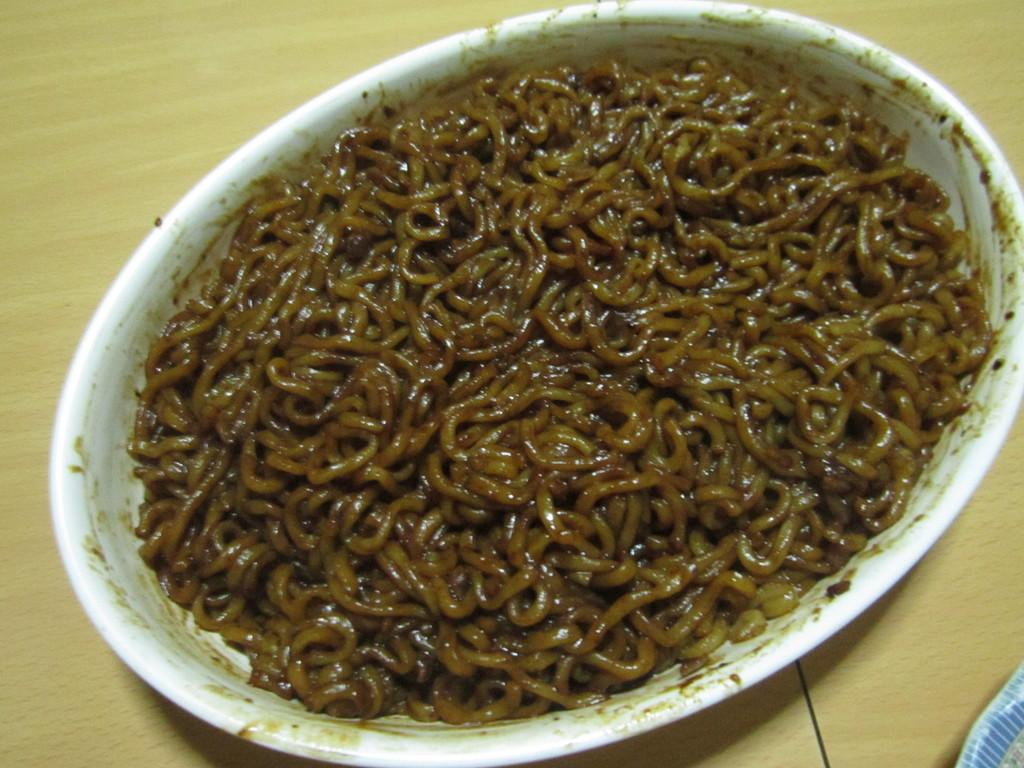What is in the bowl that is visible in the image? There are noodles in a bowl in the image. Where is the bowl placed in the image? The bowl is placed on a wooden table. What type of leather is being used to build the army's pipe in the image? There is no army or pipe present in the image, and therefore no leather can be associated with them. 